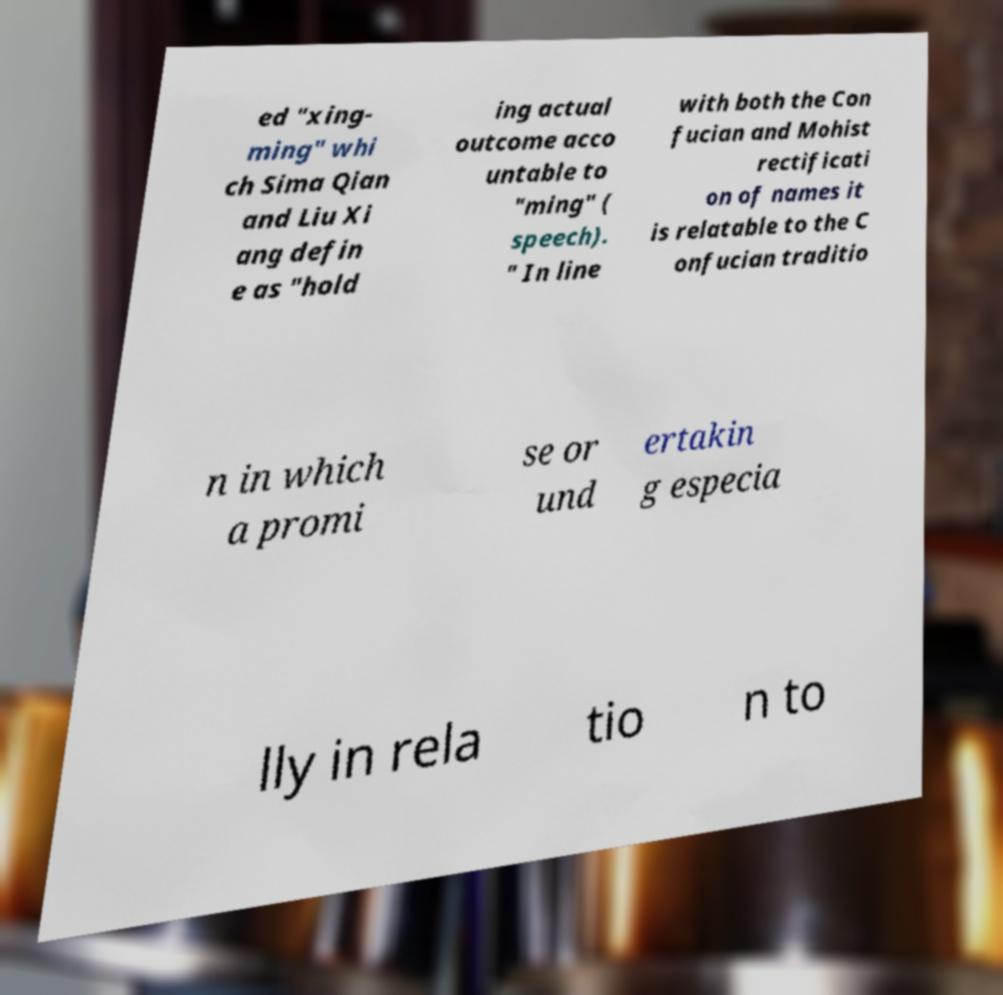Please identify and transcribe the text found in this image. ed "xing- ming" whi ch Sima Qian and Liu Xi ang defin e as "hold ing actual outcome acco untable to "ming" ( speech). " In line with both the Con fucian and Mohist rectificati on of names it is relatable to the C onfucian traditio n in which a promi se or und ertakin g especia lly in rela tio n to 